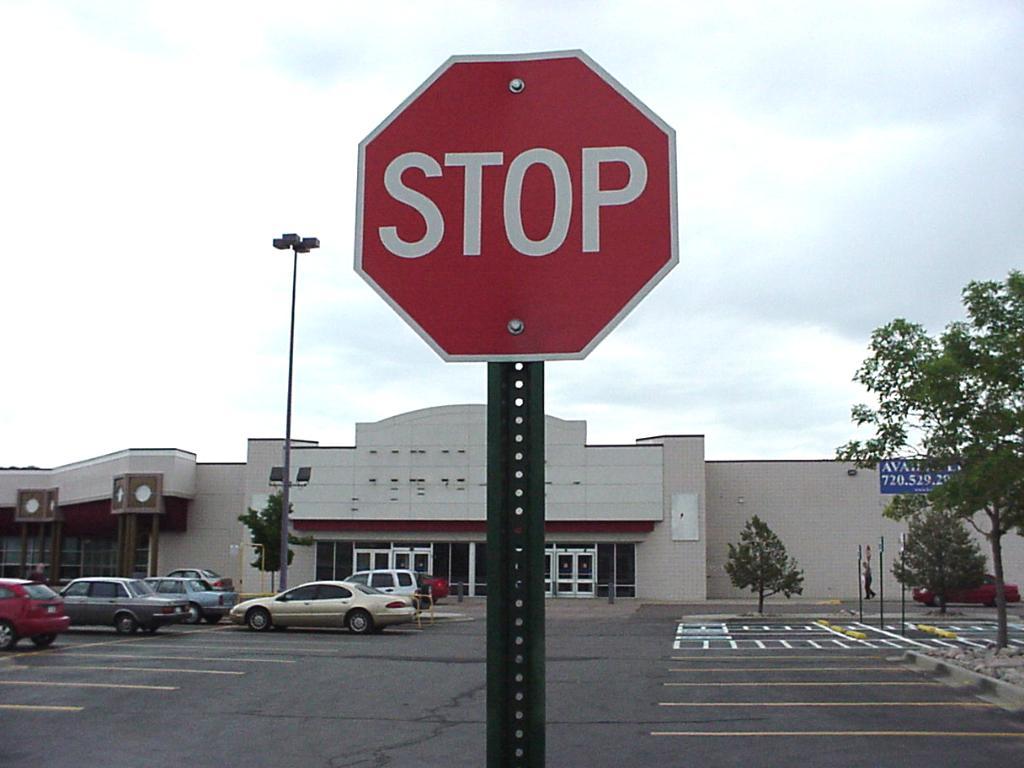What should the car do when it comes to this sign?
Offer a terse response. Stop. What are the first three numbers on the blue building sign?
Make the answer very short. 720. 